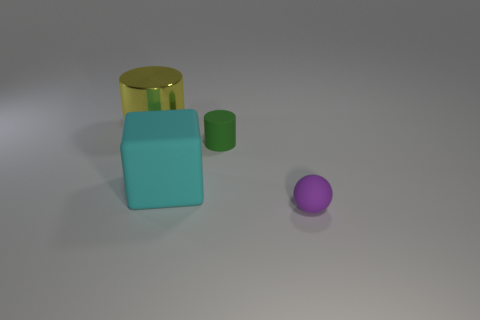Can you tell me which objects in the image are shiny? Sure, the yellow cylinder appears to have a reflective, shiny surface, as indicated by the way it reflects light compared to the other objects. 